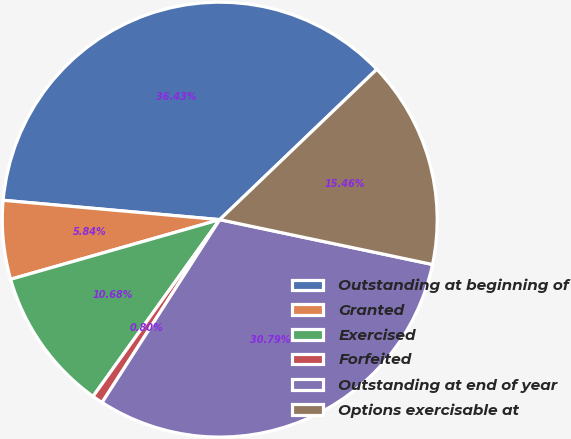Convert chart to OTSL. <chart><loc_0><loc_0><loc_500><loc_500><pie_chart><fcel>Outstanding at beginning of<fcel>Granted<fcel>Exercised<fcel>Forfeited<fcel>Outstanding at end of year<fcel>Options exercisable at<nl><fcel>36.43%<fcel>5.84%<fcel>10.68%<fcel>0.8%<fcel>30.79%<fcel>15.46%<nl></chart> 